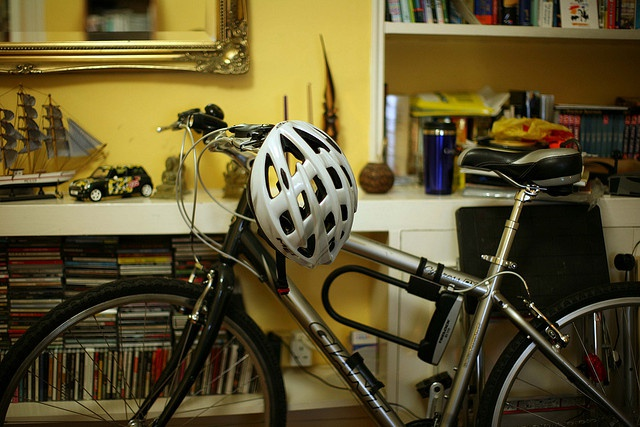Describe the objects in this image and their specific colors. I can see bicycle in black, olive, maroon, and gray tones, book in black, olive, maroon, and gray tones, boat in black, olive, and maroon tones, book in black, maroon, olive, and gray tones, and car in black, olive, and tan tones in this image. 